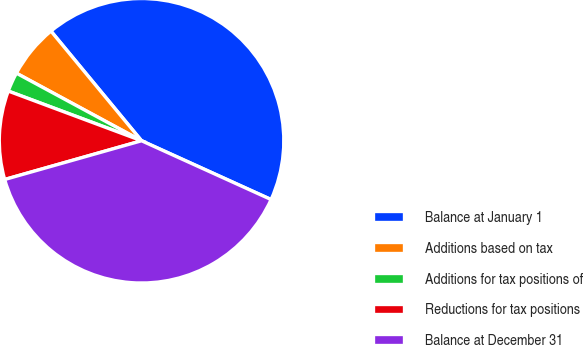Convert chart to OTSL. <chart><loc_0><loc_0><loc_500><loc_500><pie_chart><fcel>Balance at January 1<fcel>Additions based on tax<fcel>Additions for tax positions of<fcel>Reductions for tax positions<fcel>Balance at December 31<nl><fcel>42.77%<fcel>6.13%<fcel>2.2%<fcel>10.07%<fcel>38.83%<nl></chart> 